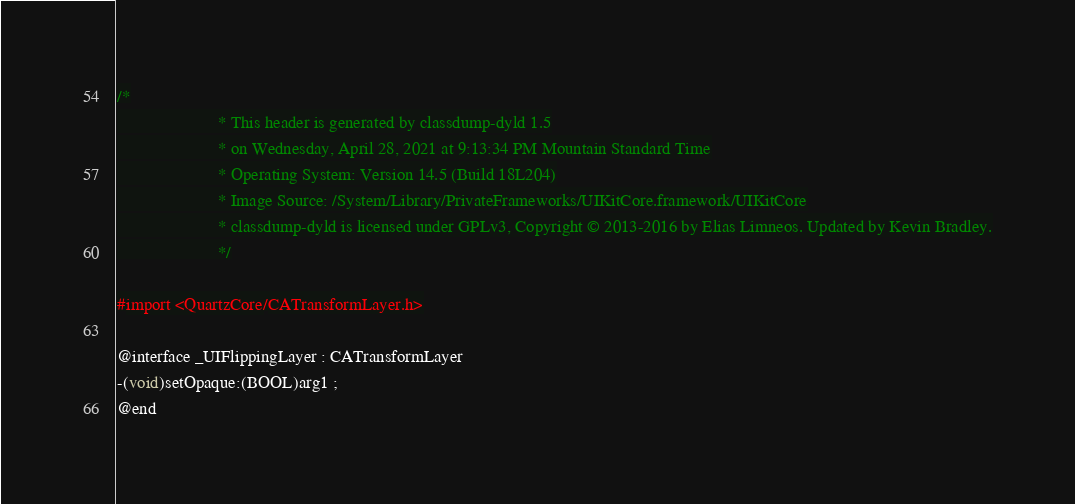Convert code to text. <code><loc_0><loc_0><loc_500><loc_500><_C_>/*
                       * This header is generated by classdump-dyld 1.5
                       * on Wednesday, April 28, 2021 at 9:13:34 PM Mountain Standard Time
                       * Operating System: Version 14.5 (Build 18L204)
                       * Image Source: /System/Library/PrivateFrameworks/UIKitCore.framework/UIKitCore
                       * classdump-dyld is licensed under GPLv3, Copyright © 2013-2016 by Elias Limneos. Updated by Kevin Bradley.
                       */

#import <QuartzCore/CATransformLayer.h>

@interface _UIFlippingLayer : CATransformLayer
-(void)setOpaque:(BOOL)arg1 ;
@end

</code> 